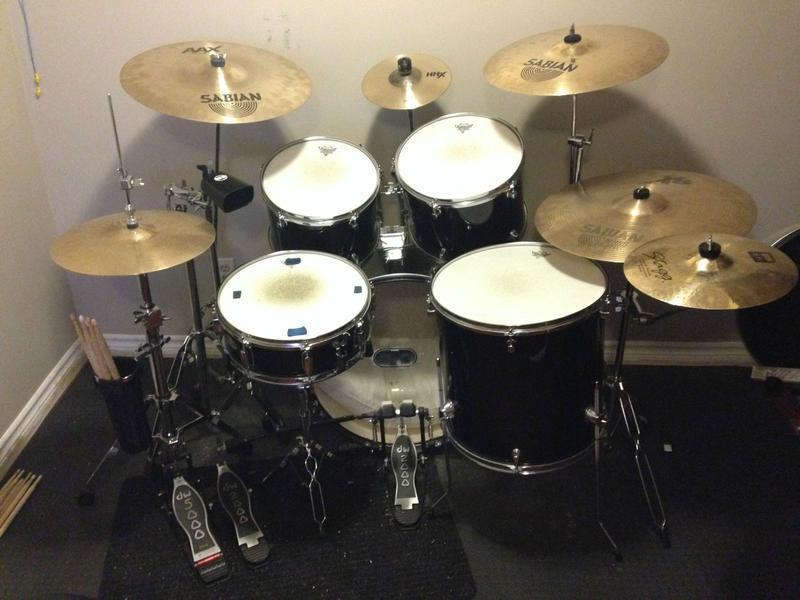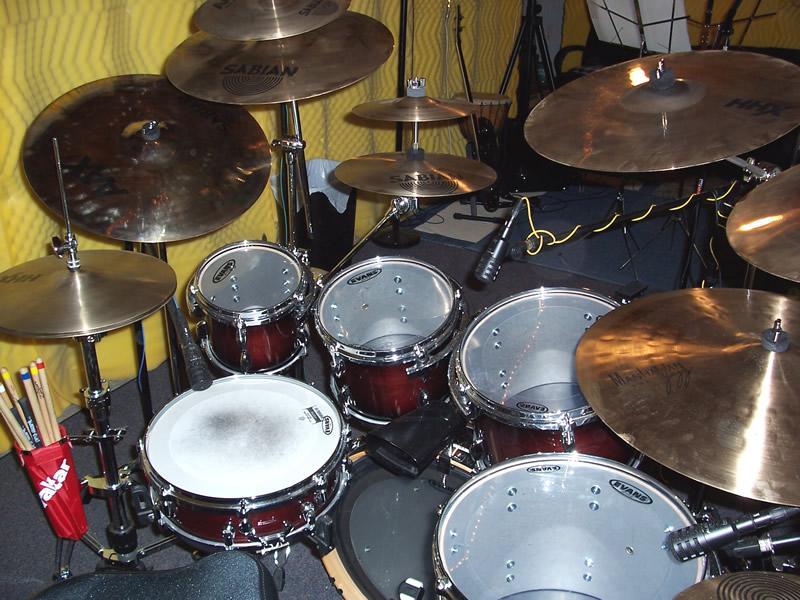The first image is the image on the left, the second image is the image on the right. Evaluate the accuracy of this statement regarding the images: "At least one human is playing an instrument.". Is it true? Answer yes or no. No. The first image is the image on the left, the second image is the image on the right. Assess this claim about the two images: "Each image contains a drum kit with multiple cymbals and cylindrical drums, but no image shows someone playing the drums.". Correct or not? Answer yes or no. Yes. 